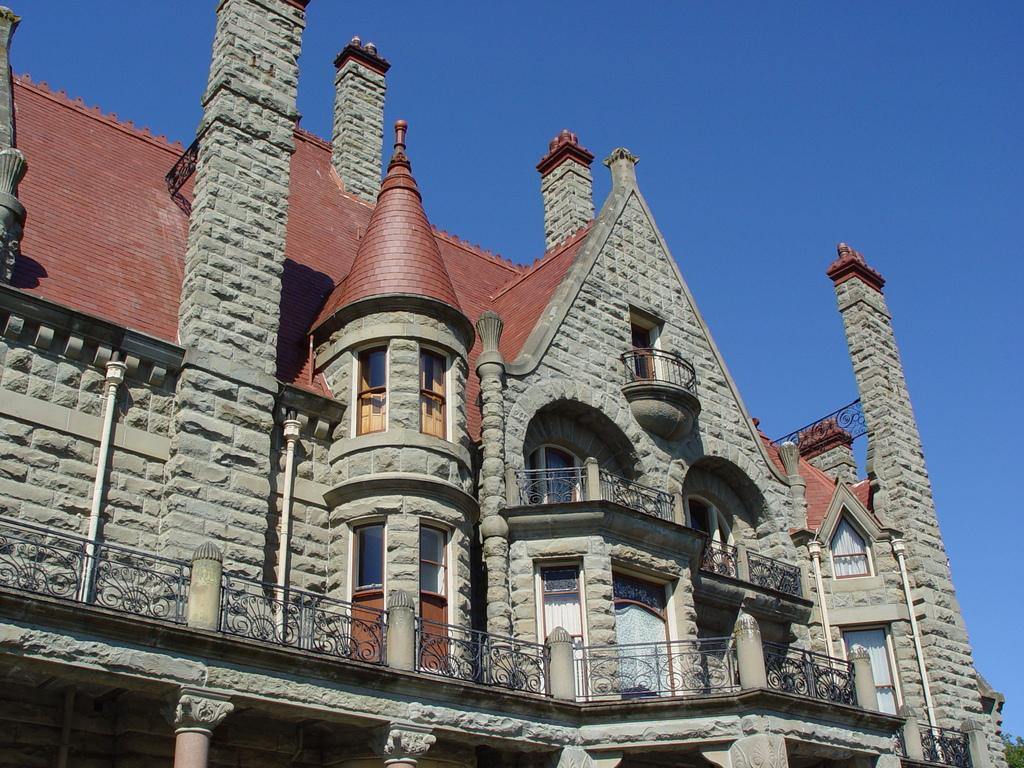What type of structure is present in the image? There is a building in the image. What colors can be seen on the building? The building has brown and gray colors. What is visible in the background of the image? The sky is visible in the background of the image. What color is the sky in the image? The sky is blue in color. How many pairs of underwear can be seen hanging from the building in the image? There are no underwear visible in the image; it only features a building and a blue sky. 